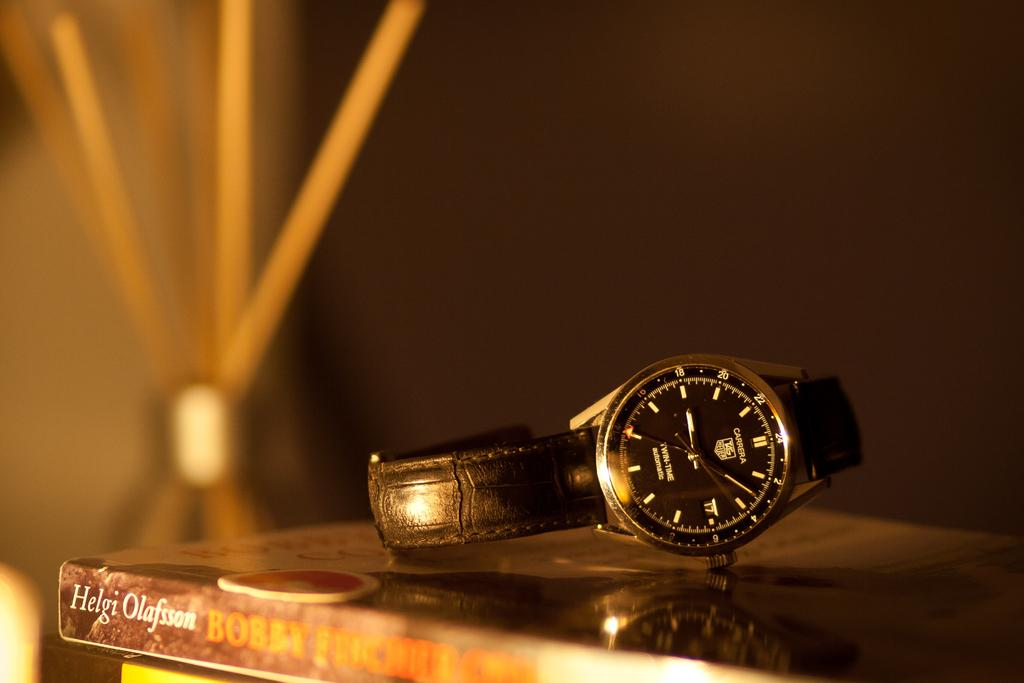Provide a one-sentence caption for the provided image. A carrera watch rests atop a stack of books. 